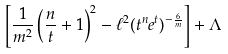<formula> <loc_0><loc_0><loc_500><loc_500>\left [ \frac { 1 } { m ^ { 2 } } \left ( \frac { n } { t } + 1 \right ) ^ { 2 } - \ell ^ { 2 } ( t ^ { n } e ^ { t } ) ^ { - \frac { 6 } { m } } \right ] + \Lambda</formula> 